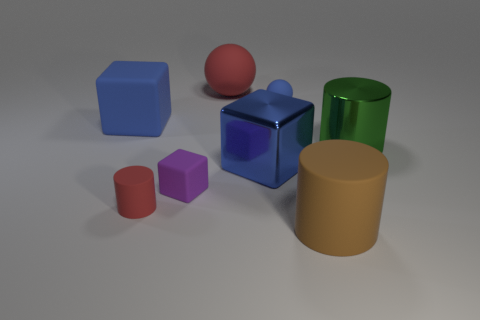Add 1 small gray cubes. How many objects exist? 9 Subtract all matte cylinders. How many cylinders are left? 1 Subtract all green cylinders. How many cylinders are left? 2 Subtract 3 cylinders. How many cylinders are left? 0 Add 8 tiny gray cylinders. How many tiny gray cylinders exist? 8 Subtract 0 blue cylinders. How many objects are left? 8 Subtract all cylinders. How many objects are left? 5 Subtract all purple cylinders. Subtract all red cubes. How many cylinders are left? 3 Subtract all cyan cylinders. How many blue blocks are left? 2 Subtract all large green matte spheres. Subtract all big matte cylinders. How many objects are left? 7 